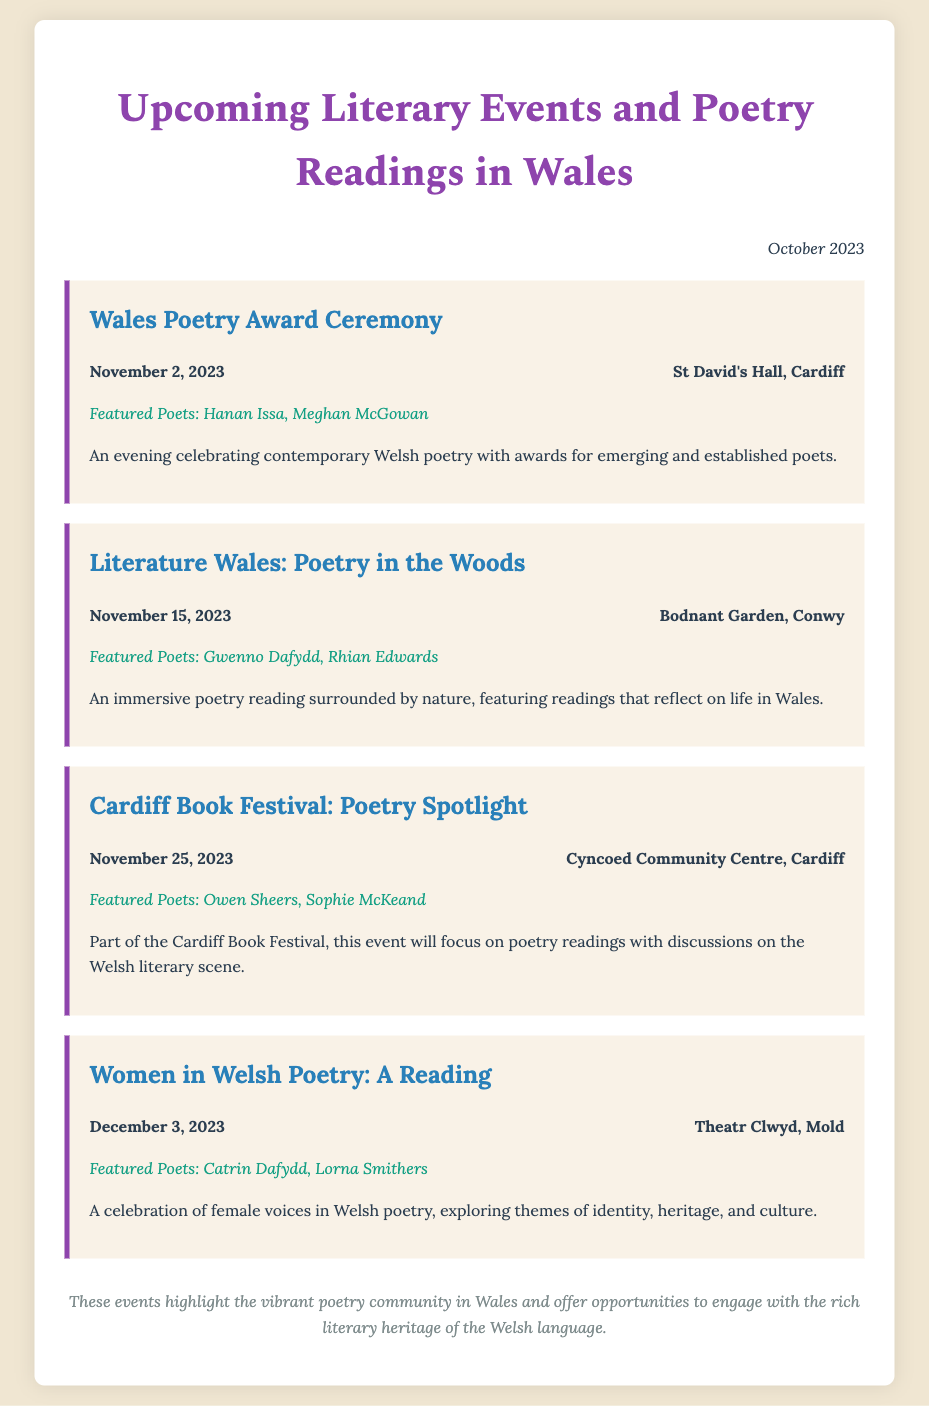What is the title of the first event? The title of the first event is mentioned at the top of the event section, which is "Wales Poetry Award Ceremony."
Answer: Wales Poetry Award Ceremony When is the Cardiff Book Festival: Poetry Spotlight scheduled? The date for the Cardiff Book Festival: Poetry Spotlight is highlighted in the event details, which is November 25, 2023.
Answer: November 25, 2023 Who are the featured poets for the event "Women in Welsh Poetry: A Reading"? The featured poets are listed at the bottom of the respective event description, which includes Catrin Dafydd and Lorna Smithers.
Answer: Catrin Dafydd, Lorna Smithers What is the venue for the Literature Wales: Poetry in the Woods event? The venue is provided in the event details, specifically stating Bodnant Garden, Conwy.
Answer: Bodnant Garden, Conwy How many literary events are listed in the document? The number of literary events can be counted from the document, which lists four distinct events.
Answer: 4 What kind of themes will be explored in the "Women in Welsh Poetry" reading? The themes are indicated in the description of the event, which mentions identity, heritage, and culture.
Answer: Identity, heritage, and culture What is the purpose of the Wales Poetry Award Ceremony? The purpose is described in the event summary, which is celebrating contemporary Welsh poetry with awards.
Answer: Celebrating contemporary Welsh poetry 